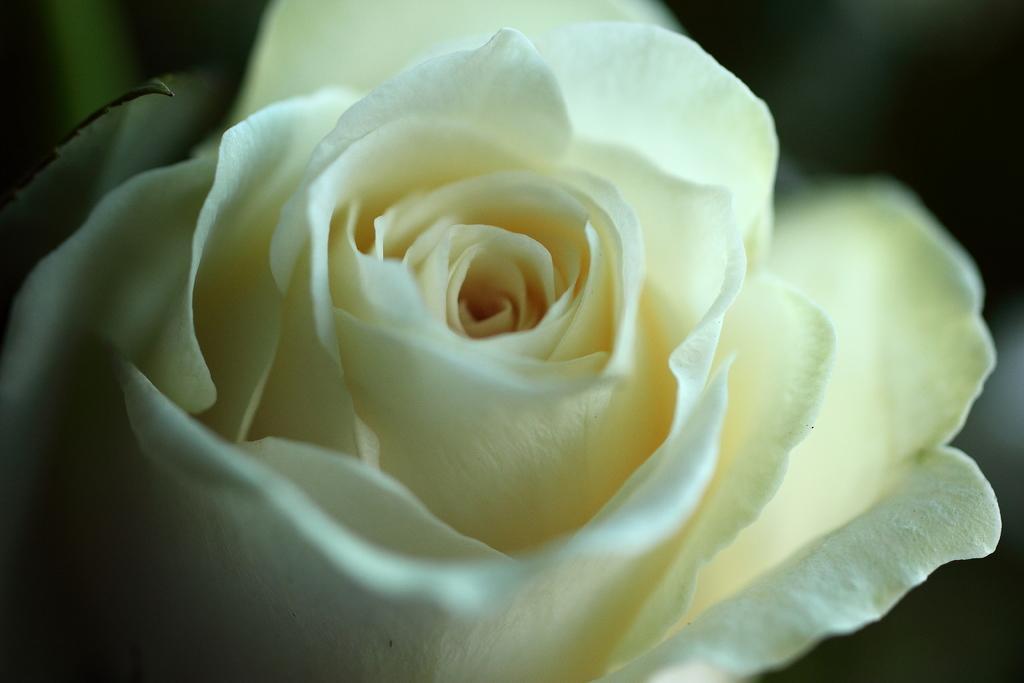Can you describe this image briefly? In this image I see a flower which is of white in color and I see that it is dark in the background. 